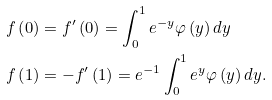Convert formula to latex. <formula><loc_0><loc_0><loc_500><loc_500>f \left ( 0 \right ) & = f ^ { \prime } \left ( 0 \right ) = \int _ { 0 } ^ { 1 } e ^ { - y } \varphi \left ( y \right ) d y \\ f \left ( 1 \right ) & = - f ^ { \prime } \left ( 1 \right ) = e ^ { - 1 } \int _ { 0 } ^ { 1 } e ^ { y } \varphi \left ( y \right ) d y .</formula> 